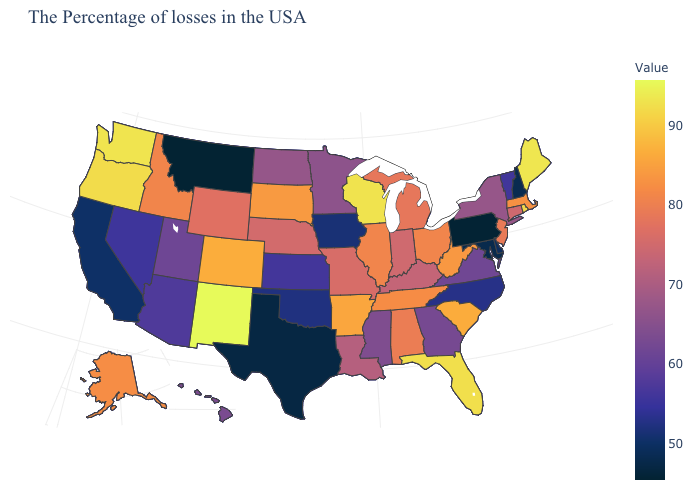Among the states that border Alabama , does Georgia have the lowest value?
Short answer required. Yes. Does New Mexico have a lower value than Massachusetts?
Quick response, please. No. Does New Hampshire have the lowest value in the Northeast?
Be succinct. No. Does the map have missing data?
Give a very brief answer. No. 